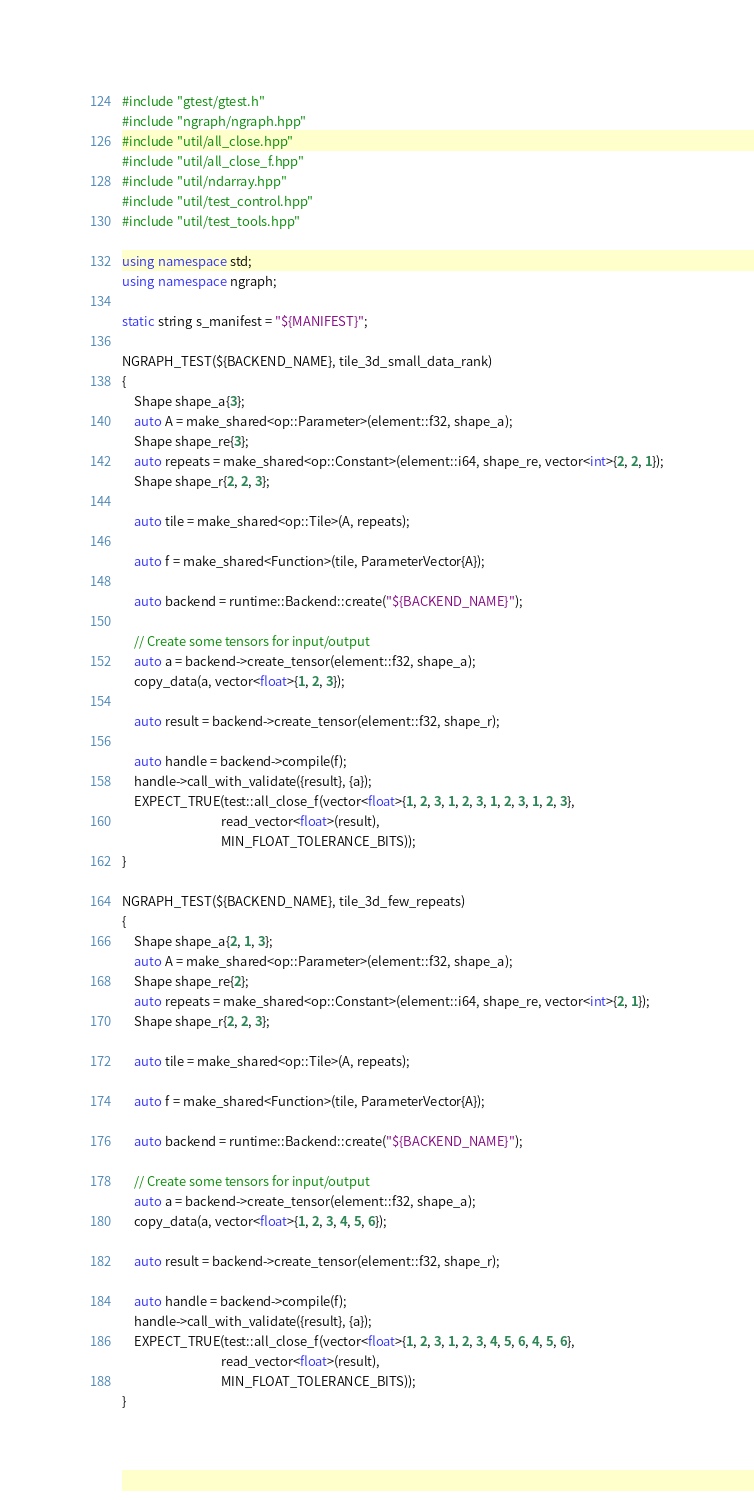<code> <loc_0><loc_0><loc_500><loc_500><_C++_>#include "gtest/gtest.h"
#include "ngraph/ngraph.hpp"
#include "util/all_close.hpp"
#include "util/all_close_f.hpp"
#include "util/ndarray.hpp"
#include "util/test_control.hpp"
#include "util/test_tools.hpp"

using namespace std;
using namespace ngraph;

static string s_manifest = "${MANIFEST}";

NGRAPH_TEST(${BACKEND_NAME}, tile_3d_small_data_rank)
{
    Shape shape_a{3};
    auto A = make_shared<op::Parameter>(element::f32, shape_a);
    Shape shape_re{3};
    auto repeats = make_shared<op::Constant>(element::i64, shape_re, vector<int>{2, 2, 1});
    Shape shape_r{2, 2, 3};

    auto tile = make_shared<op::Tile>(A, repeats);

    auto f = make_shared<Function>(tile, ParameterVector{A});

    auto backend = runtime::Backend::create("${BACKEND_NAME}");

    // Create some tensors for input/output
    auto a = backend->create_tensor(element::f32, shape_a);
    copy_data(a, vector<float>{1, 2, 3});

    auto result = backend->create_tensor(element::f32, shape_r);

    auto handle = backend->compile(f);
    handle->call_with_validate({result}, {a});
    EXPECT_TRUE(test::all_close_f(vector<float>{1, 2, 3, 1, 2, 3, 1, 2, 3, 1, 2, 3},
                                  read_vector<float>(result),
                                  MIN_FLOAT_TOLERANCE_BITS));
}

NGRAPH_TEST(${BACKEND_NAME}, tile_3d_few_repeats)
{
    Shape shape_a{2, 1, 3};
    auto A = make_shared<op::Parameter>(element::f32, shape_a);
    Shape shape_re{2};
    auto repeats = make_shared<op::Constant>(element::i64, shape_re, vector<int>{2, 1});
    Shape shape_r{2, 2, 3};

    auto tile = make_shared<op::Tile>(A, repeats);

    auto f = make_shared<Function>(tile, ParameterVector{A});

    auto backend = runtime::Backend::create("${BACKEND_NAME}");

    // Create some tensors for input/output
    auto a = backend->create_tensor(element::f32, shape_a);
    copy_data(a, vector<float>{1, 2, 3, 4, 5, 6});

    auto result = backend->create_tensor(element::f32, shape_r);

    auto handle = backend->compile(f);
    handle->call_with_validate({result}, {a});
    EXPECT_TRUE(test::all_close_f(vector<float>{1, 2, 3, 1, 2, 3, 4, 5, 6, 4, 5, 6},
                                  read_vector<float>(result),
                                  MIN_FLOAT_TOLERANCE_BITS));
}
</code> 